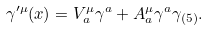<formula> <loc_0><loc_0><loc_500><loc_500>\gamma ^ { \prime \mu } ( x ) = V ^ { \mu } _ { a } \gamma ^ { a } + A ^ { \mu } _ { a } \gamma ^ { a } \gamma _ { ( 5 ) } .</formula> 